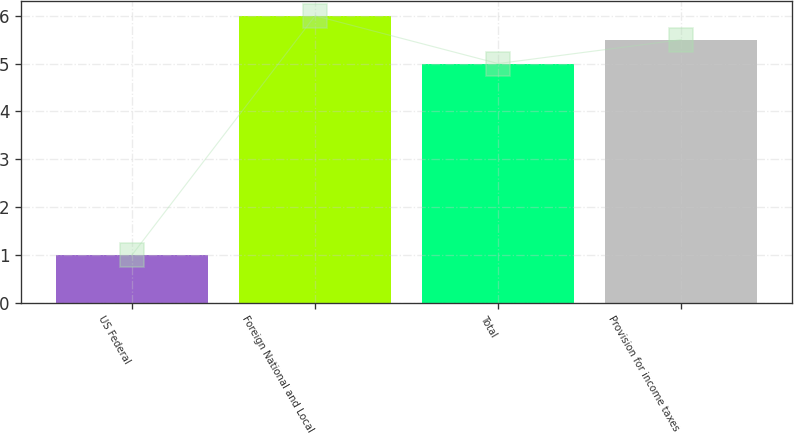Convert chart to OTSL. <chart><loc_0><loc_0><loc_500><loc_500><bar_chart><fcel>US Federal<fcel>Foreign National and Local<fcel>Total<fcel>Provision for income taxes<nl><fcel>1<fcel>6<fcel>5<fcel>5.5<nl></chart> 